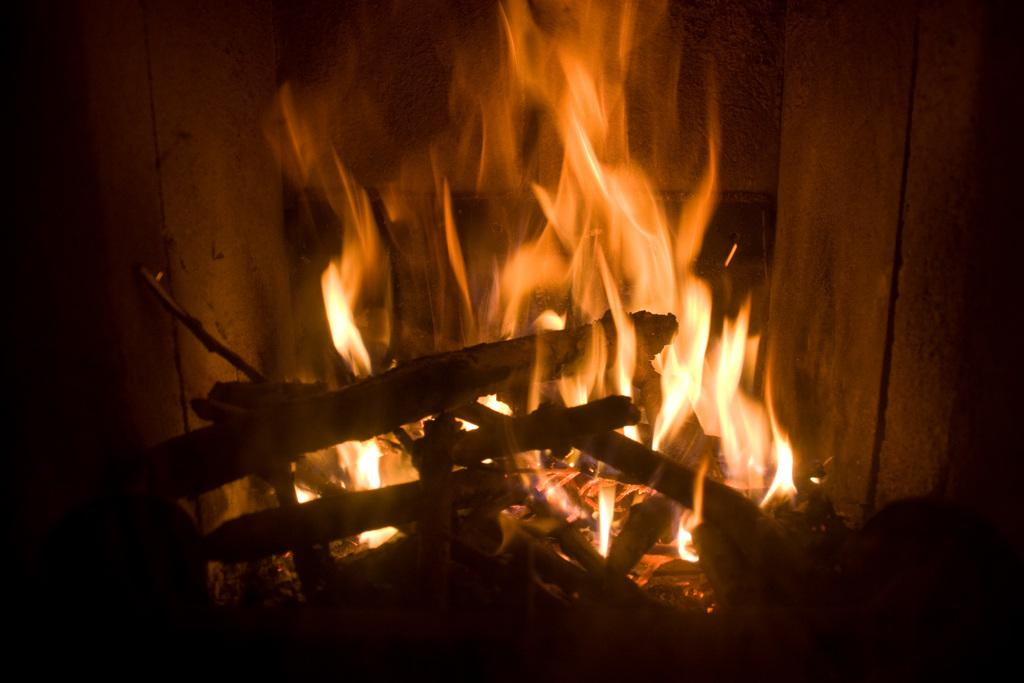What type of objects are made of wood and visible in the image? There are wood sticks in the image. What is the source of heat or light in the image? There is a flame in the image. What type of throne is present in the image? There is no throne present in the image. How many dogs can be seen interacting with the wood sticks in the image? There are no dogs present in the image. 